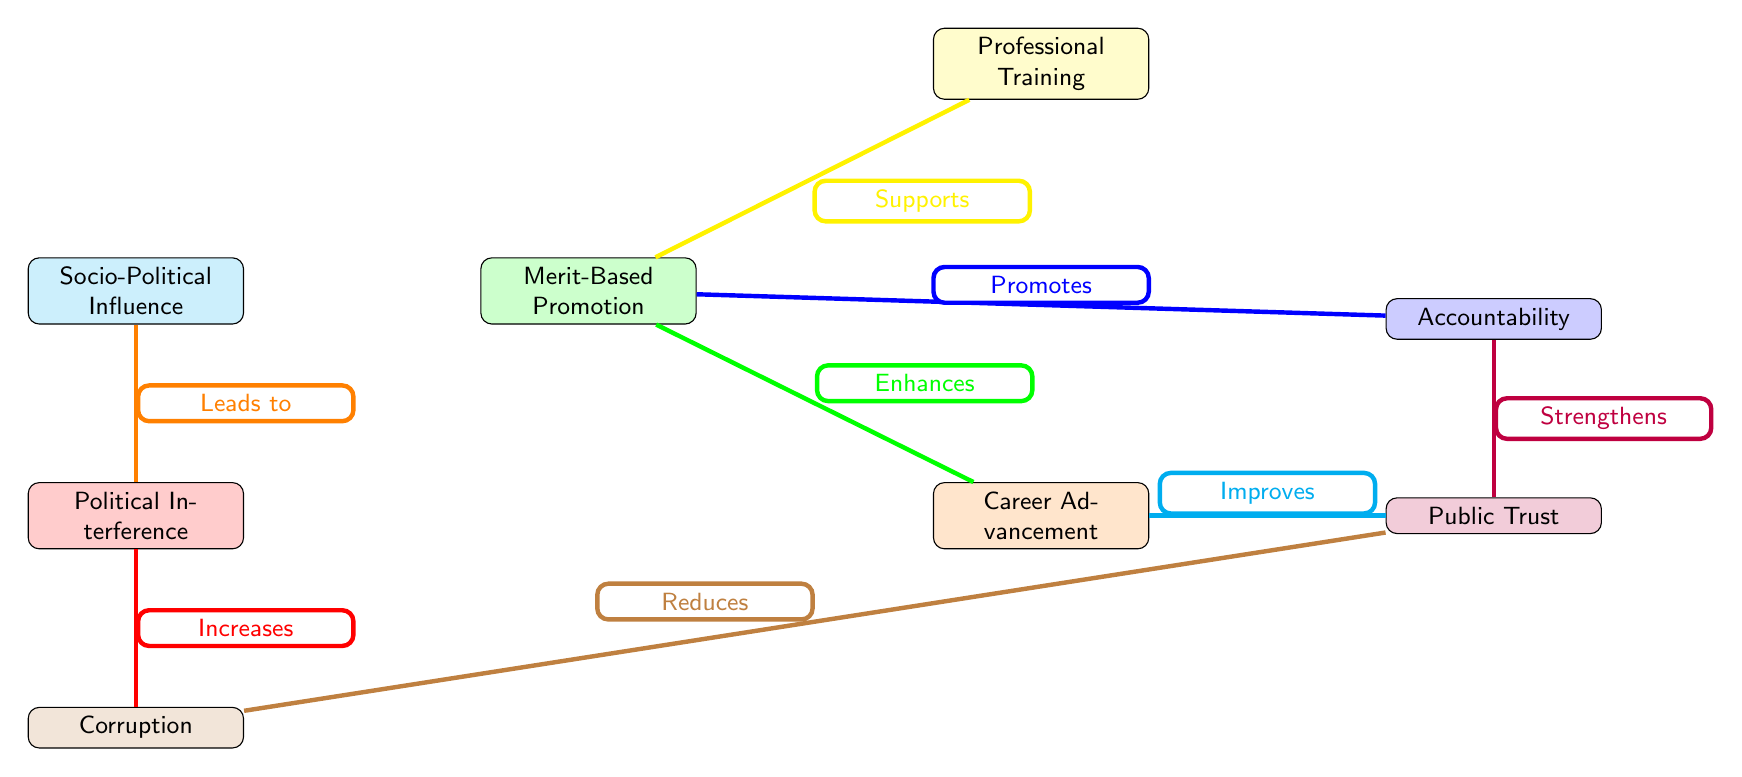What is the first node in the diagram? The first node in the diagram is "Socio-Political Influence," as it is located at the top of the visual and serves as the starting point for the flow.
Answer: Socio-Political Influence How many nodes are present in the diagram? Counting the nodes visually arranged in the diagram, we have a total of seven distinct nodes: "Socio-Political Influence," "Merit-Based Promotion," "Professional Training," "Career Advancement," "Public Trust," "Accountability," and "Political Interference."
Answer: 7 What relationship exists between "Merit-Based Promotion" and "Career Advancement"? There is a direct relationship where "Merit-Based Promotion" enhances "Career Advancement," indicated by the arrow showing the direction of influence between these nodes.
Answer: Enhances Which node leads to "Political Interference"? The node that leads to "Political Interference" is "Socio-Political Influence," as it has a direct connection indicating it as the source of influence towards that node.
Answer: Socio-Political Influence How does "Corruption" affect "Public Trust"? "Corruption" reduces "Public Trust," which is indicated by the arrow connecting "Corruption" to "Public Trust" and labels the relationship as a reduction in trust.
Answer: Reduces What promotes "Accountability"? "Merit-Based Promotion" promotes "Accountability," indicated by the arrow pointing from "Merit-Based Promotion" to "Accountability" showing this direct promotional relationship.
Answer: Promotes What does "Professional Training" support in the diagram? "Professional Training" supports "Merit-Based Promotion," as shown by the arrow leading from "Professional Training" to "Merit-Based Promotion" indicating a supportive relationship.
Answer: Merit-Based Promotion Which two nodes are directly connected with thick orange edges in the diagram? The nodes directly connected by thick orange edges are "Socio-Political Influence" and "Political Interference," indicating their significant relationship.
Answer: Socio-Political Influence and Political Interference How can "Career Advancement" improve "Public Trust"? "Career Advancement" improves "Public Trust," shown by the arrow leading from "Career Advancement" to "Public Trust," indicating that career advancement has a positive effect on public perception.
Answer: Improves 